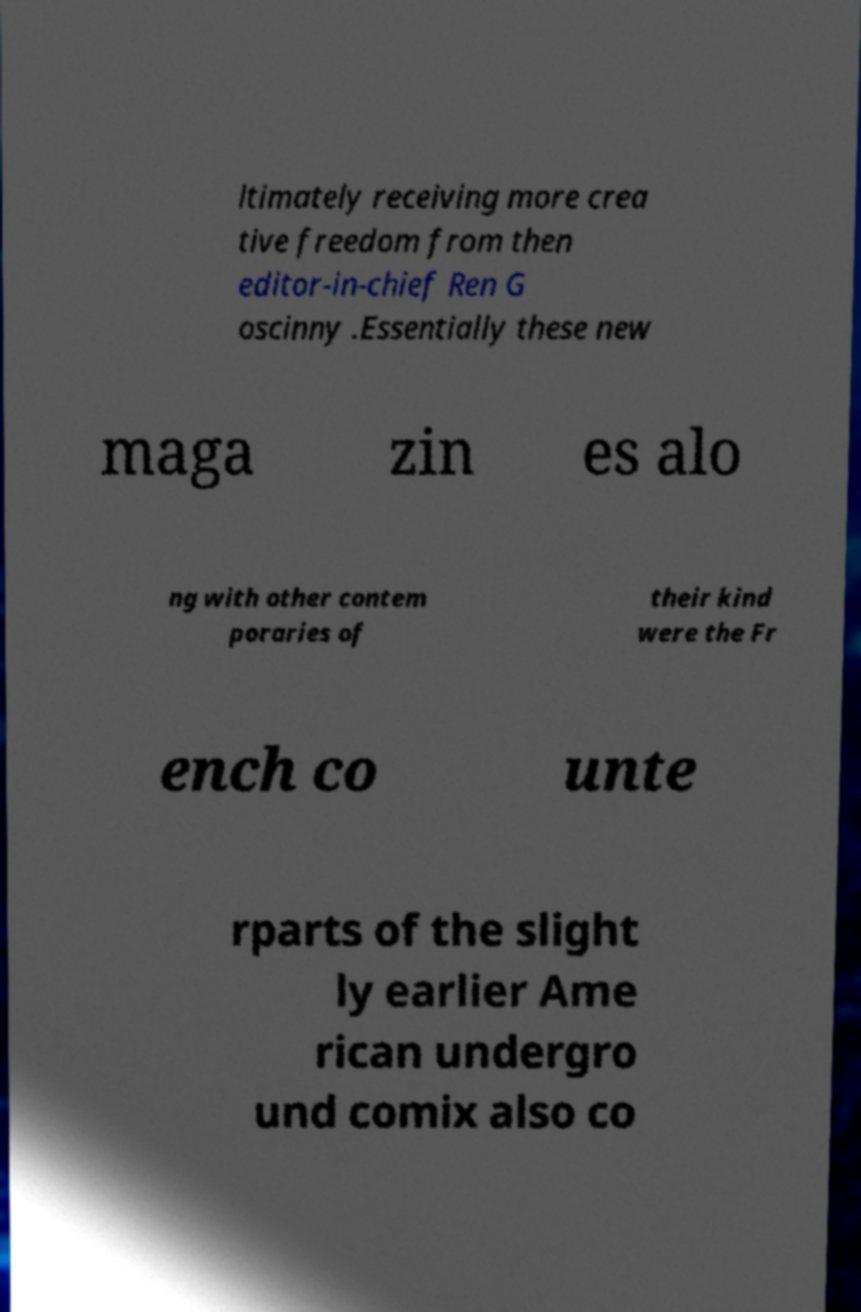What messages or text are displayed in this image? I need them in a readable, typed format. ltimately receiving more crea tive freedom from then editor-in-chief Ren G oscinny .Essentially these new maga zin es alo ng with other contem poraries of their kind were the Fr ench co unte rparts of the slight ly earlier Ame rican undergro und comix also co 